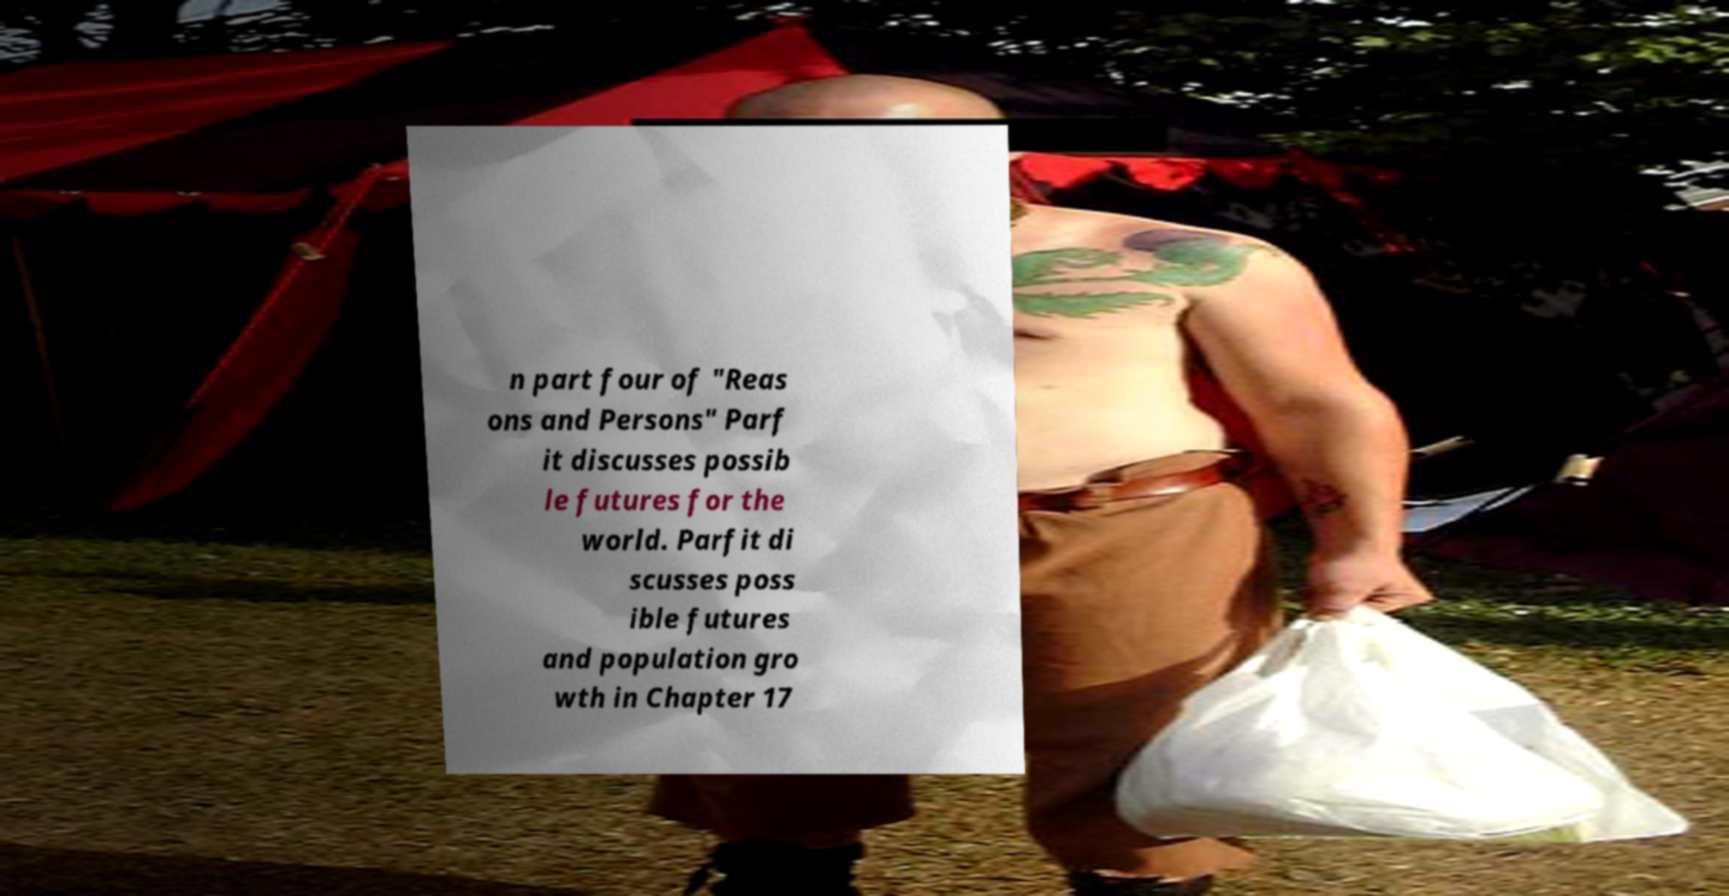There's text embedded in this image that I need extracted. Can you transcribe it verbatim? n part four of "Reas ons and Persons" Parf it discusses possib le futures for the world. Parfit di scusses poss ible futures and population gro wth in Chapter 17 